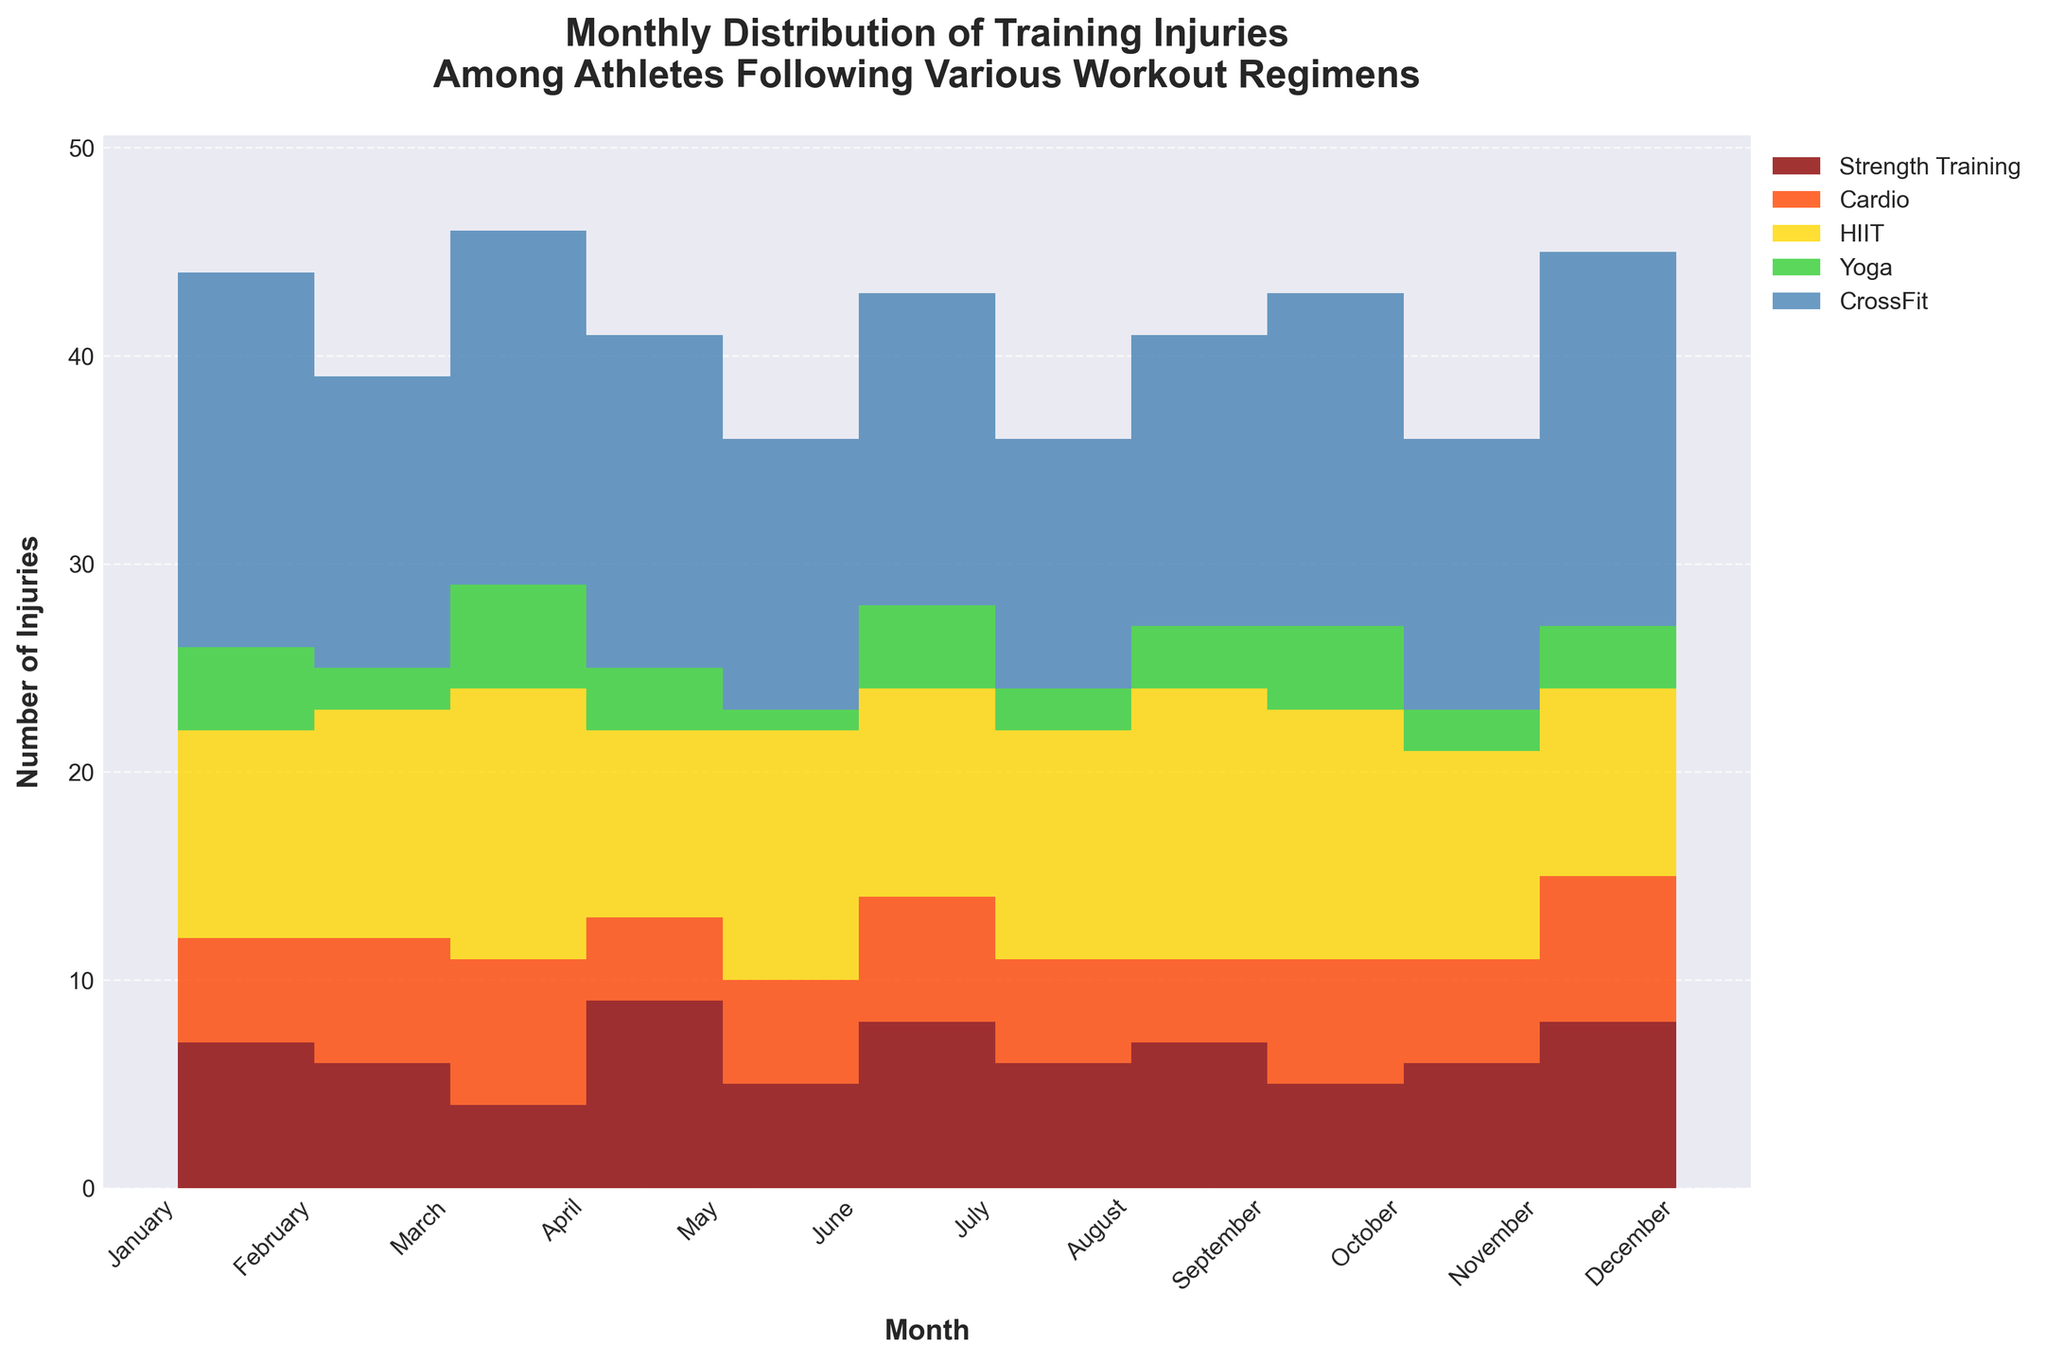What is the title of the figure? The title of the figure is usually displayed at the top of the visual representation. This helps the viewer to quickly understand the purpose of the chart. In this case, it is written at the top of the figure
Answer: Monthly Distribution of Training Injuries Among Athletes Following Various Workout Regimens How many different workout regimens are included in the figure? The figure shows different workout regimens in the legend section, typically in various colors to differentiate them. By counting these, we can identify the number of workout regimens represented
Answer: 5 Which month had the highest number of injuries for CrossFit? By scanning the area corresponding to CrossFit, which is depicted in a unique color, across all months from January to December, we can spot the month with the tallest area section indicating the highest injuries
Answer: February and December What is the total number of injuries in November? To find this, sum the values of all workout regimens for November. This involves adding the injuries from Strength Training, Cardio, HIIT, Yoga, and CrossFit for that month
Answer: 36 In which month did Yoga have the least number of injuries? By observing the area color representing Yoga for each month and identifying the smallest height in the corresponding section, we can pinpoint the month with the fewest injuries for Yoga
Answer: June and November How does the number of injuries in March for Strength Training compare to Cardio? By looking at the chart sections corresponding to March and comparing the heights of the areas for Strength Training and Cardio, we determine which regimen had more injuries
Answer: Strength Training had more injuries (6 vs. 5) Which workout regimen had the most consistent number of injuries throughout the year? To identify the most consistent regimen, observe the variations in the height of each regimen's area throughout the months. The regimen with the least variation is the most consistent
Answer: Cardio What is the combined total of injuries in August for HIIT and Yoga? To find this, add the injuries reported for HIIT and Yoga in August by looking at the height of the corresponding sections
Answer: 13 Which two months have the greatest difference in the number of injuries for Strength Training? By observing the area heights for Strength Training across all months, identify and subtract the values of the two months with the maximum difference
Answer: May and April (9 - 4 = 5) During which month did HIIT have the second highest number of injuries? By scanning the chart for the HIIT section, find the months with the two highest heights, and select the second highest
Answer: April 